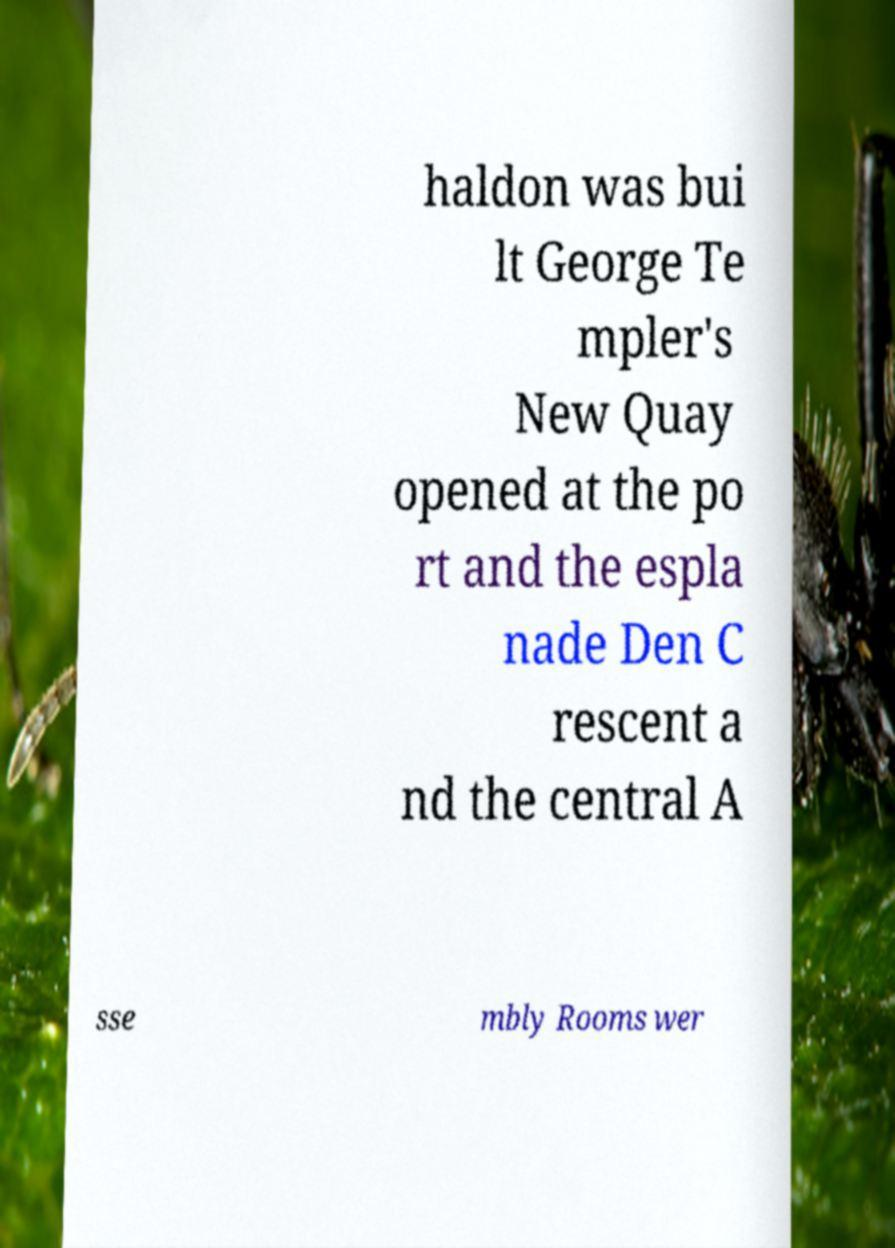For documentation purposes, I need the text within this image transcribed. Could you provide that? haldon was bui lt George Te mpler's New Quay opened at the po rt and the espla nade Den C rescent a nd the central A sse mbly Rooms wer 